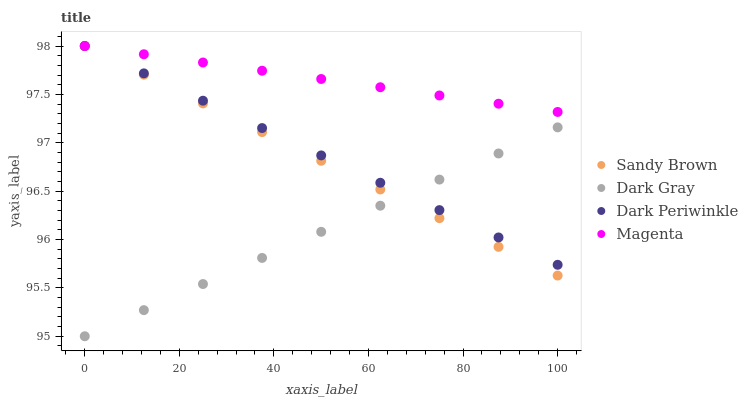Does Dark Gray have the minimum area under the curve?
Answer yes or no. Yes. Does Magenta have the maximum area under the curve?
Answer yes or no. Yes. Does Sandy Brown have the minimum area under the curve?
Answer yes or no. No. Does Sandy Brown have the maximum area under the curve?
Answer yes or no. No. Is Dark Periwinkle the smoothest?
Answer yes or no. Yes. Is Sandy Brown the roughest?
Answer yes or no. Yes. Is Magenta the smoothest?
Answer yes or no. No. Is Magenta the roughest?
Answer yes or no. No. Does Dark Gray have the lowest value?
Answer yes or no. Yes. Does Sandy Brown have the lowest value?
Answer yes or no. No. Does Dark Periwinkle have the highest value?
Answer yes or no. Yes. Is Dark Gray less than Magenta?
Answer yes or no. Yes. Is Magenta greater than Dark Gray?
Answer yes or no. Yes. Does Sandy Brown intersect Dark Periwinkle?
Answer yes or no. Yes. Is Sandy Brown less than Dark Periwinkle?
Answer yes or no. No. Is Sandy Brown greater than Dark Periwinkle?
Answer yes or no. No. Does Dark Gray intersect Magenta?
Answer yes or no. No. 